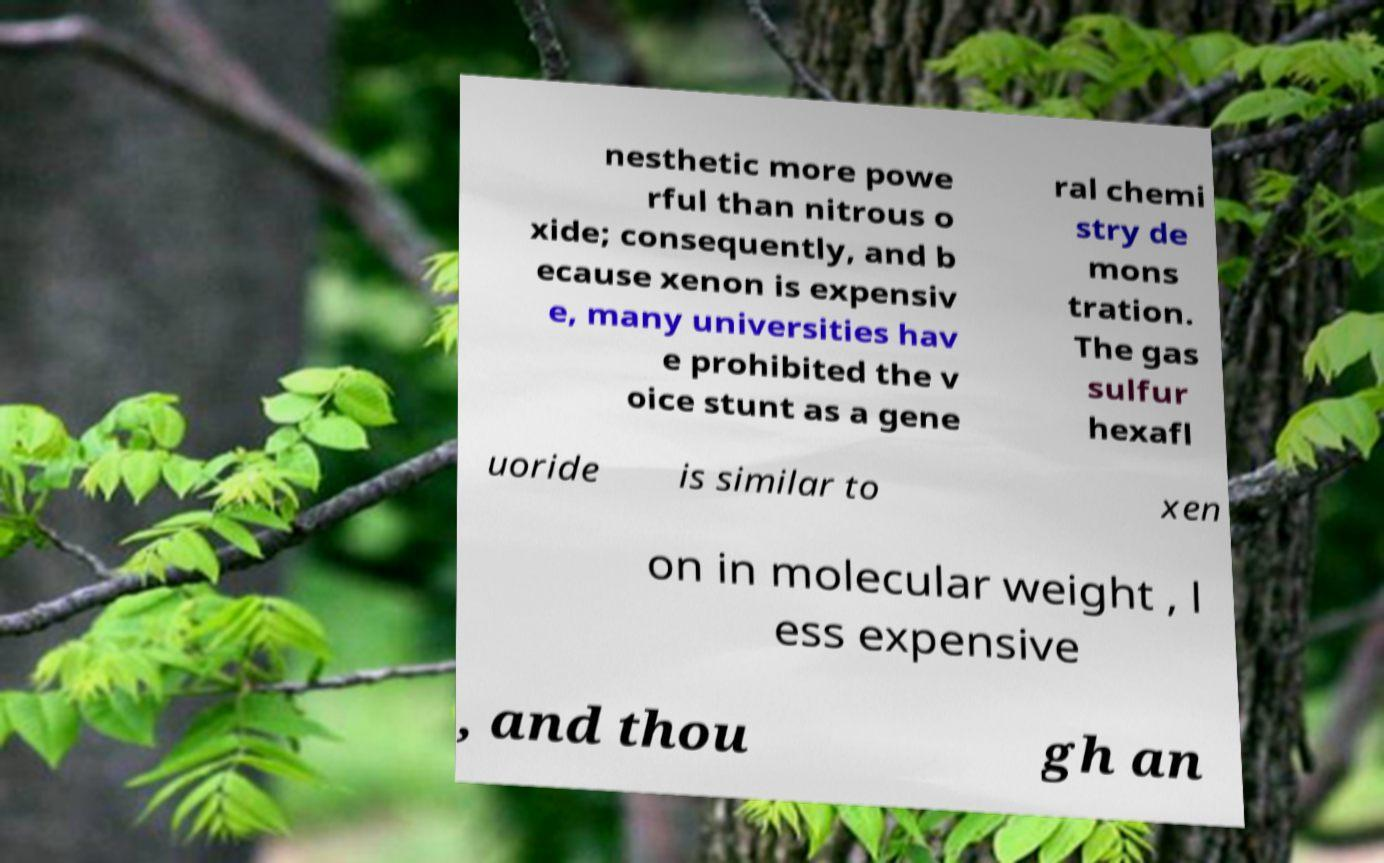For documentation purposes, I need the text within this image transcribed. Could you provide that? nesthetic more powe rful than nitrous o xide; consequently, and b ecause xenon is expensiv e, many universities hav e prohibited the v oice stunt as a gene ral chemi stry de mons tration. The gas sulfur hexafl uoride is similar to xen on in molecular weight , l ess expensive , and thou gh an 